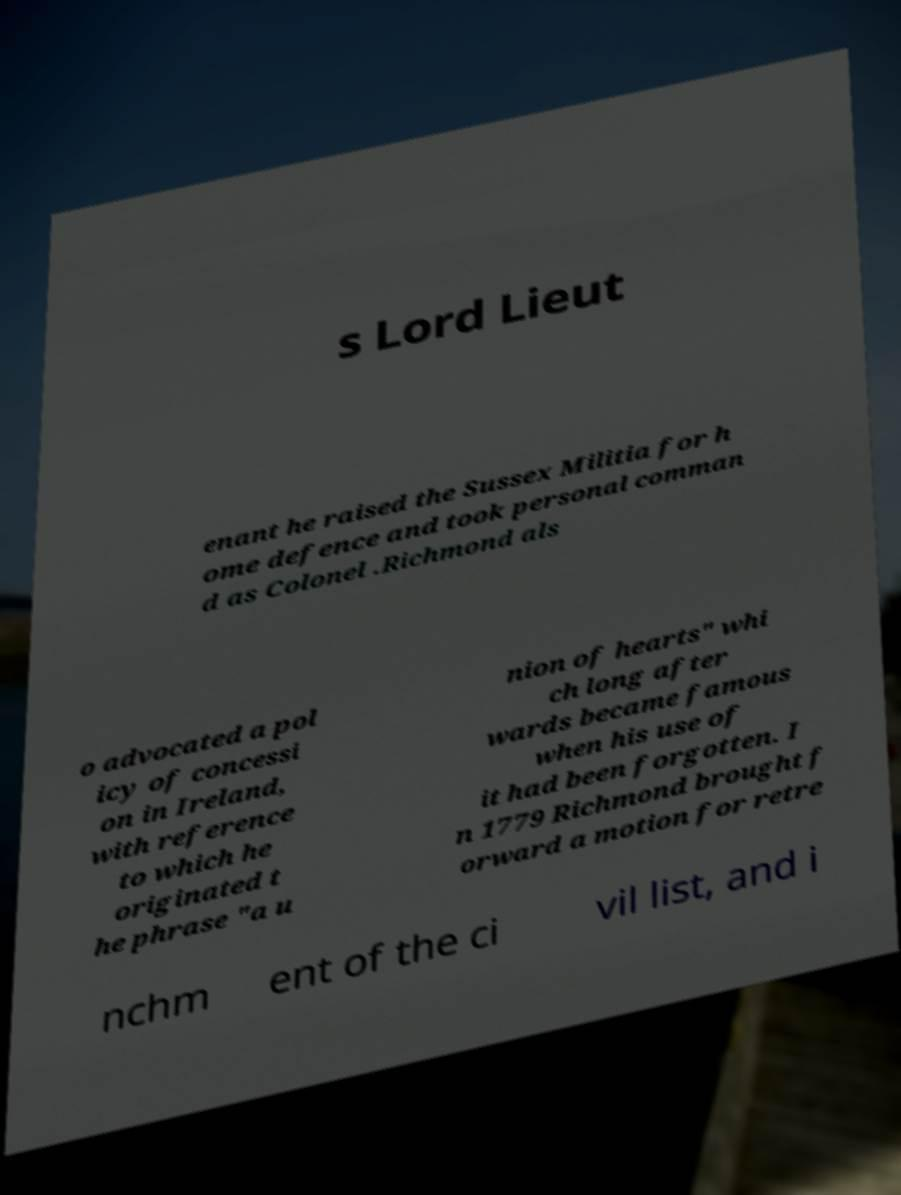For documentation purposes, I need the text within this image transcribed. Could you provide that? s Lord Lieut enant he raised the Sussex Militia for h ome defence and took personal comman d as Colonel .Richmond als o advocated a pol icy of concessi on in Ireland, with reference to which he originated t he phrase "a u nion of hearts" whi ch long after wards became famous when his use of it had been forgotten. I n 1779 Richmond brought f orward a motion for retre nchm ent of the ci vil list, and i 